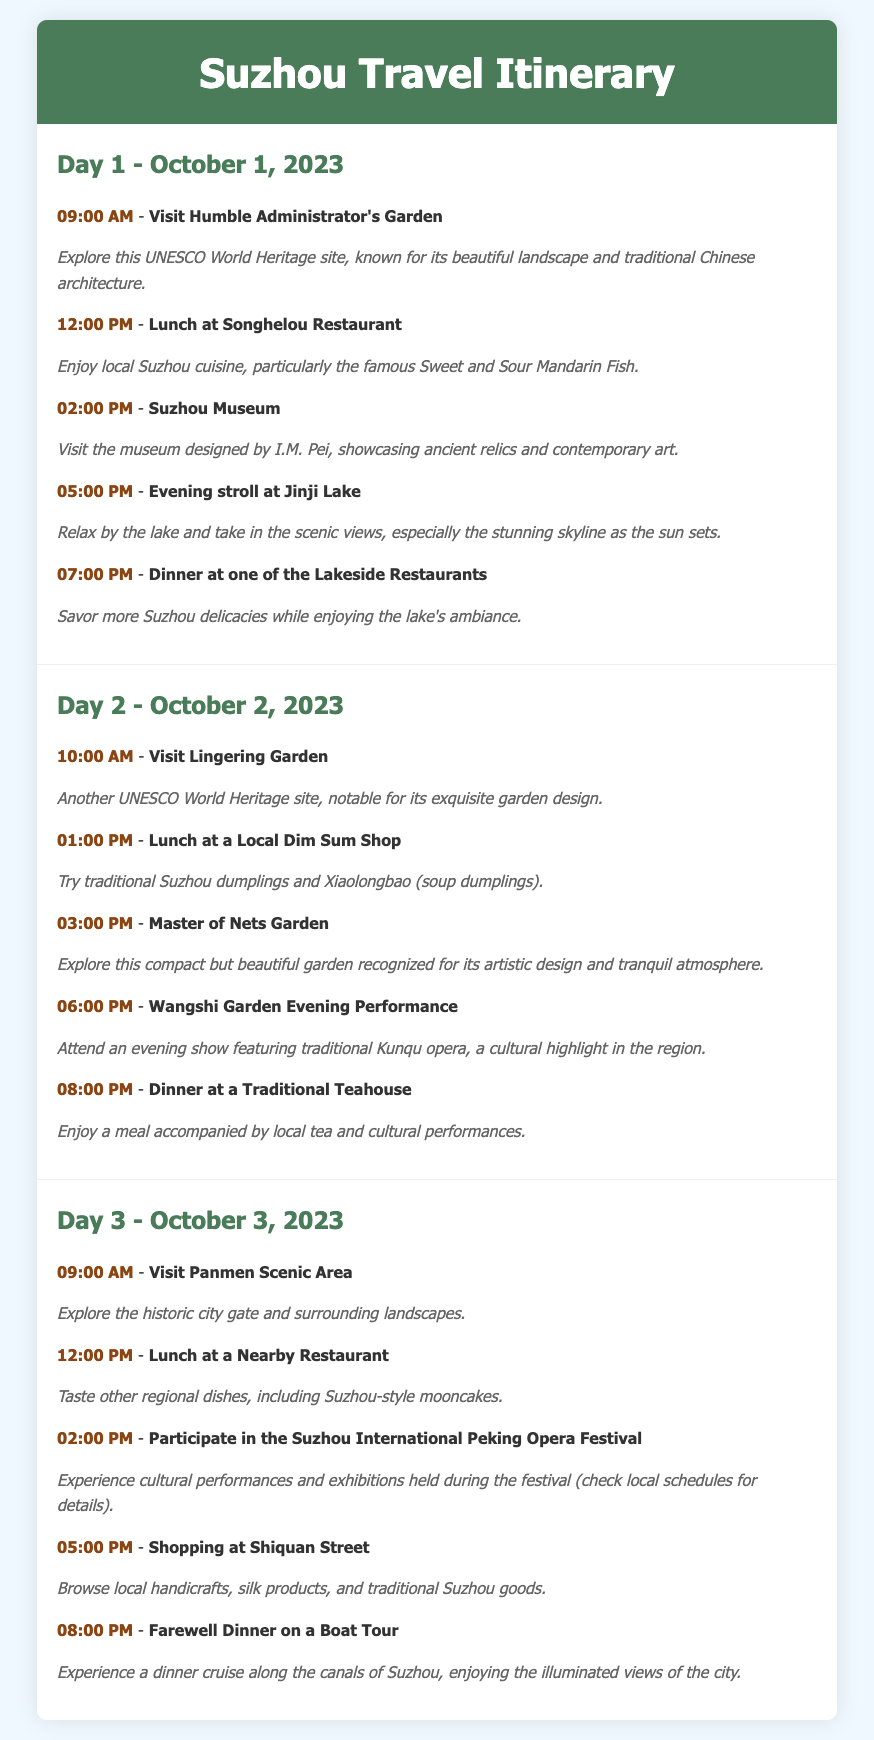What is the first activity on Day 1? The first activity on Day 1 is visiting the Humble Administrator's Garden at 09:00 AM.
Answer: Visit Humble Administrator's Garden What time is the Wangshi Garden Evening Performance? The Wangshi Garden Evening Performance takes place at 06:00 PM on Day 2.
Answer: 06:00 PM What cuisine is highlighted for lunch on Day 1? The lunch on Day 1 features local Suzhou cuisine, particularly Sweet and Sour Mandarin Fish.
Answer: Sweet and Sour Mandarin Fish How many UNESCO World Heritage sites are visited during the trip? The itinerary includes two UNESCO World Heritage sites: Humble Administrator's Garden and Lingering Garden.
Answer: Two What festival is happening on Day 3? On Day 3, the Suzhou International Peking Opera Festival is taking place.
Answer: Suzhou International Peking Opera Festival What type of performance is featured at the evening show on Day 2? The performance featured at the evening show on Day 2 is traditional Kunqu opera.
Answer: Traditional Kunqu opera What is scheduled for dinner on Day 3? The dinner on Day 3 is a farewell dinner on a boat tour.
Answer: Farewell Dinner on a Boat Tour What activity takes place at 05:00 PM on Day 3? At 05:00 PM on Day 3, shopping at Shiquan Street is scheduled.
Answer: Shopping at Shiquan Street 